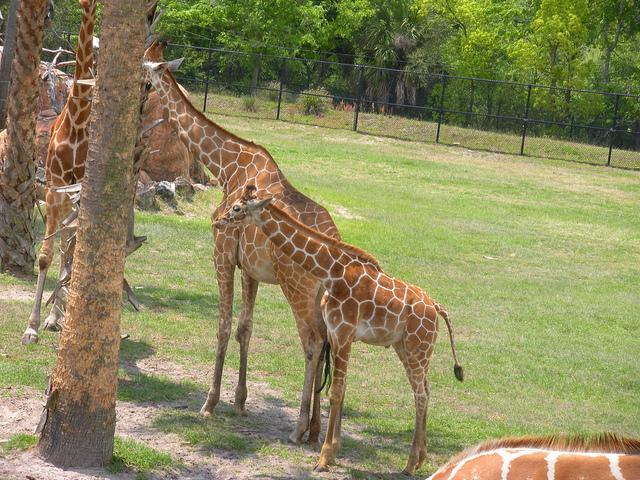Why are the animals enclosed in one area? zoo 